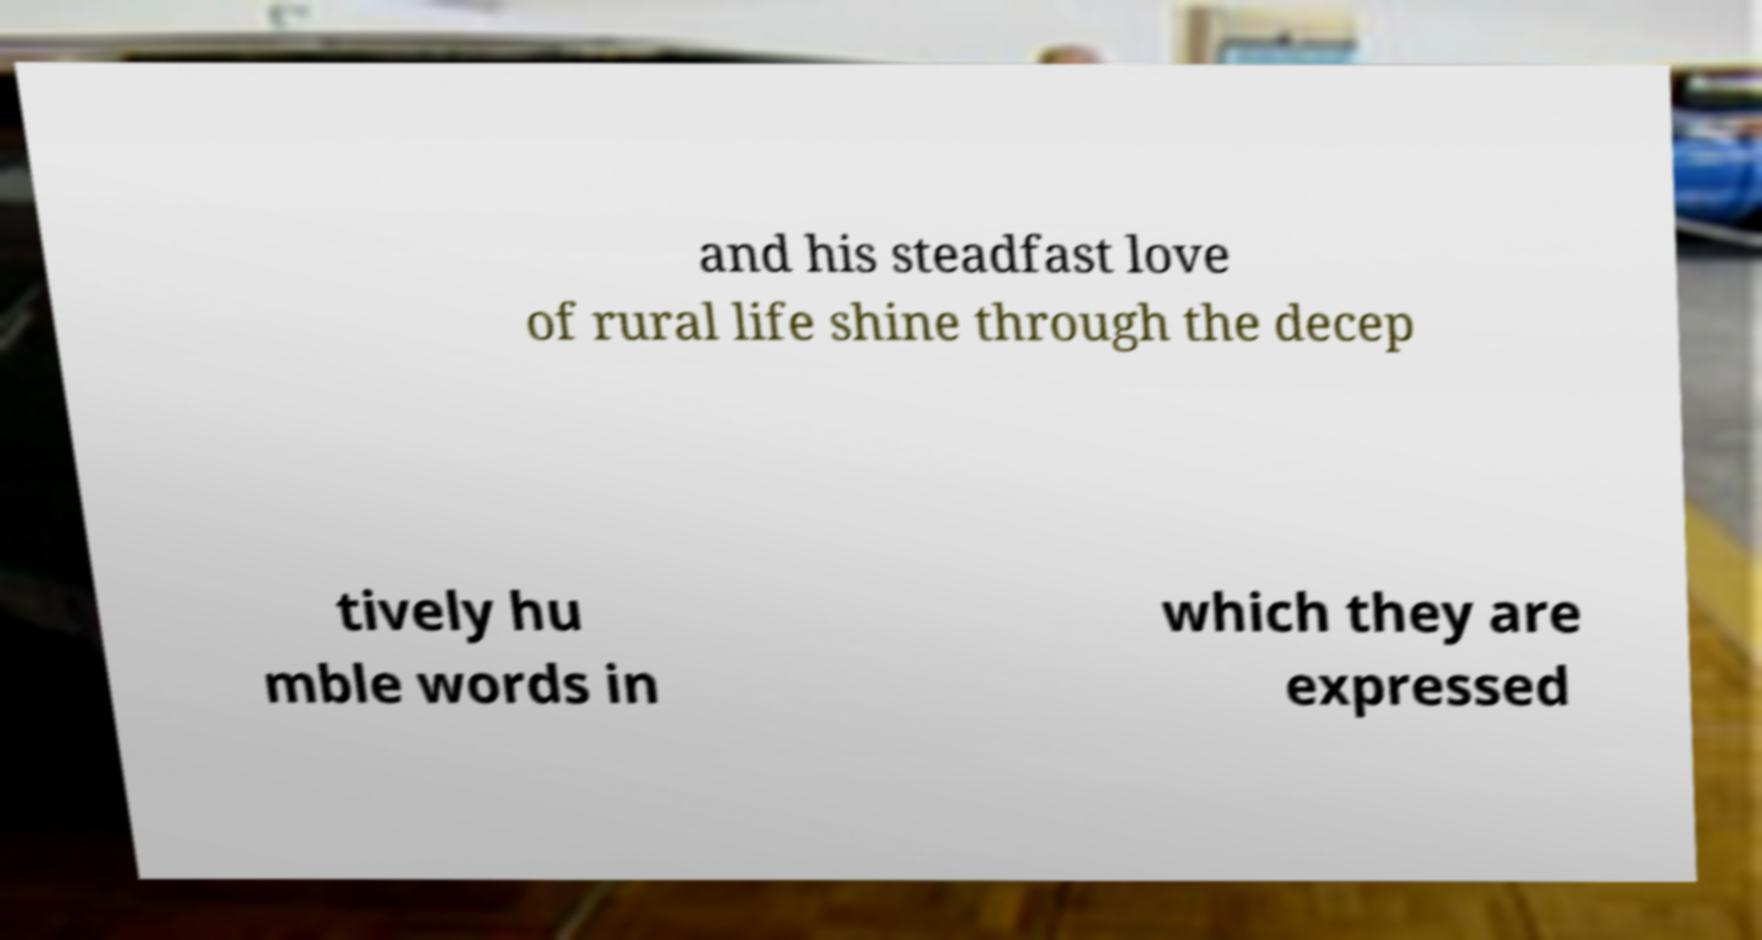There's text embedded in this image that I need extracted. Can you transcribe it verbatim? and his steadfast love of rural life shine through the decep tively hu mble words in which they are expressed 